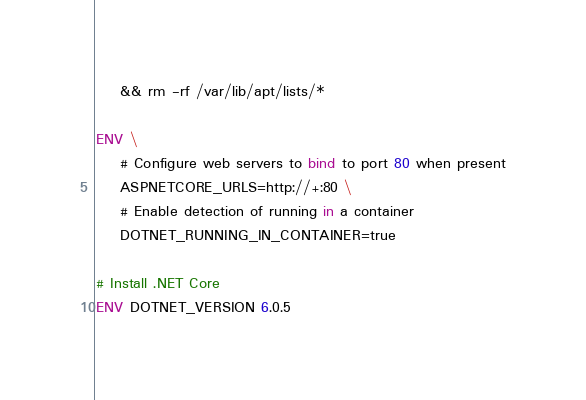Convert code to text. <code><loc_0><loc_0><loc_500><loc_500><_Dockerfile_>    && rm -rf /var/lib/apt/lists/*

ENV \
    # Configure web servers to bind to port 80 when present
    ASPNETCORE_URLS=http://+:80 \
    # Enable detection of running in a container
    DOTNET_RUNNING_IN_CONTAINER=true

# Install .NET Core
ENV DOTNET_VERSION 6.0.5
</code> 